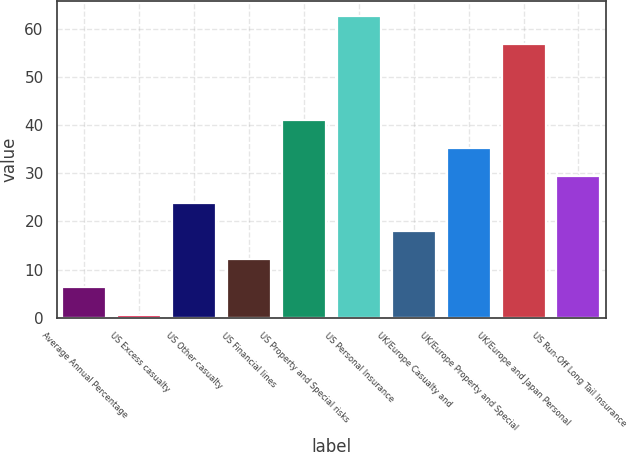<chart> <loc_0><loc_0><loc_500><loc_500><bar_chart><fcel>Average Annual Percentage<fcel>US Excess casualty<fcel>US Other casualty<fcel>US Financial lines<fcel>US Property and Special risks<fcel>US Personal Insurance<fcel>UK/Europe Casualty and<fcel>UK/Europe Property and Special<fcel>UK/Europe and Japan Personal<fcel>US Run-Off Long Tail Insurance<nl><fcel>6.31<fcel>0.5<fcel>23.74<fcel>12.12<fcel>41.17<fcel>62.71<fcel>17.93<fcel>35.36<fcel>56.9<fcel>29.55<nl></chart> 